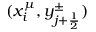Convert formula to latex. <formula><loc_0><loc_0><loc_500><loc_500>( x _ { i } ^ { \mu } , y _ { j + \frac { 1 } { 2 } } ^ { \pm } )</formula> 